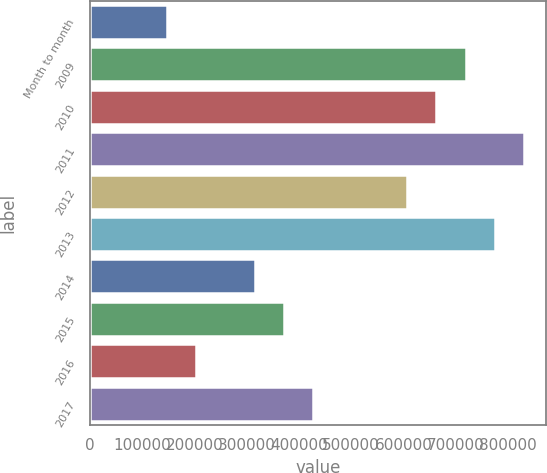Convert chart to OTSL. <chart><loc_0><loc_0><loc_500><loc_500><bar_chart><fcel>Month to month<fcel>2009<fcel>2010<fcel>2011<fcel>2012<fcel>2013<fcel>2014<fcel>2015<fcel>2016<fcel>2017<nl><fcel>147000<fcel>719400<fcel>663200<fcel>831800<fcel>607000<fcel>775600<fcel>315600<fcel>371800<fcel>203200<fcel>428000<nl></chart> 